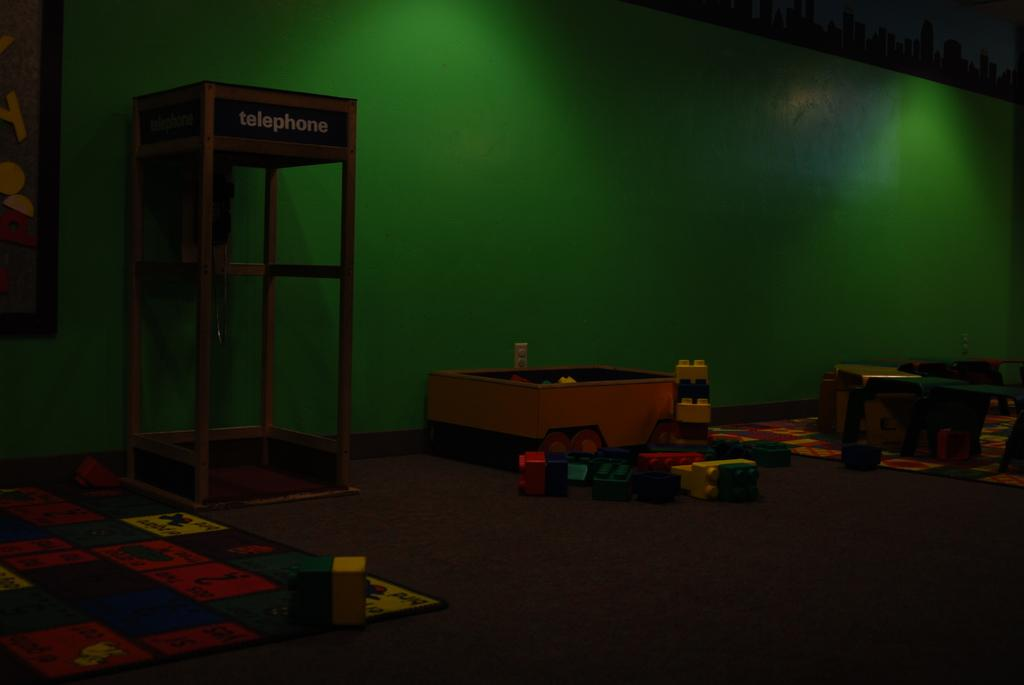What objects are placed on the floor in the image? There are building blocks placed on the floor in the image. What structure can be seen on the left side of the image? There is a telephone booth on the left side of the image. What color is the wall visible in the background of the image? There is a green color wall in the background of the image. What type of authority figure can be seen in the image? There is no authority figure present in the image. Is there a fan visible in the image? There is no fan present in the image. 